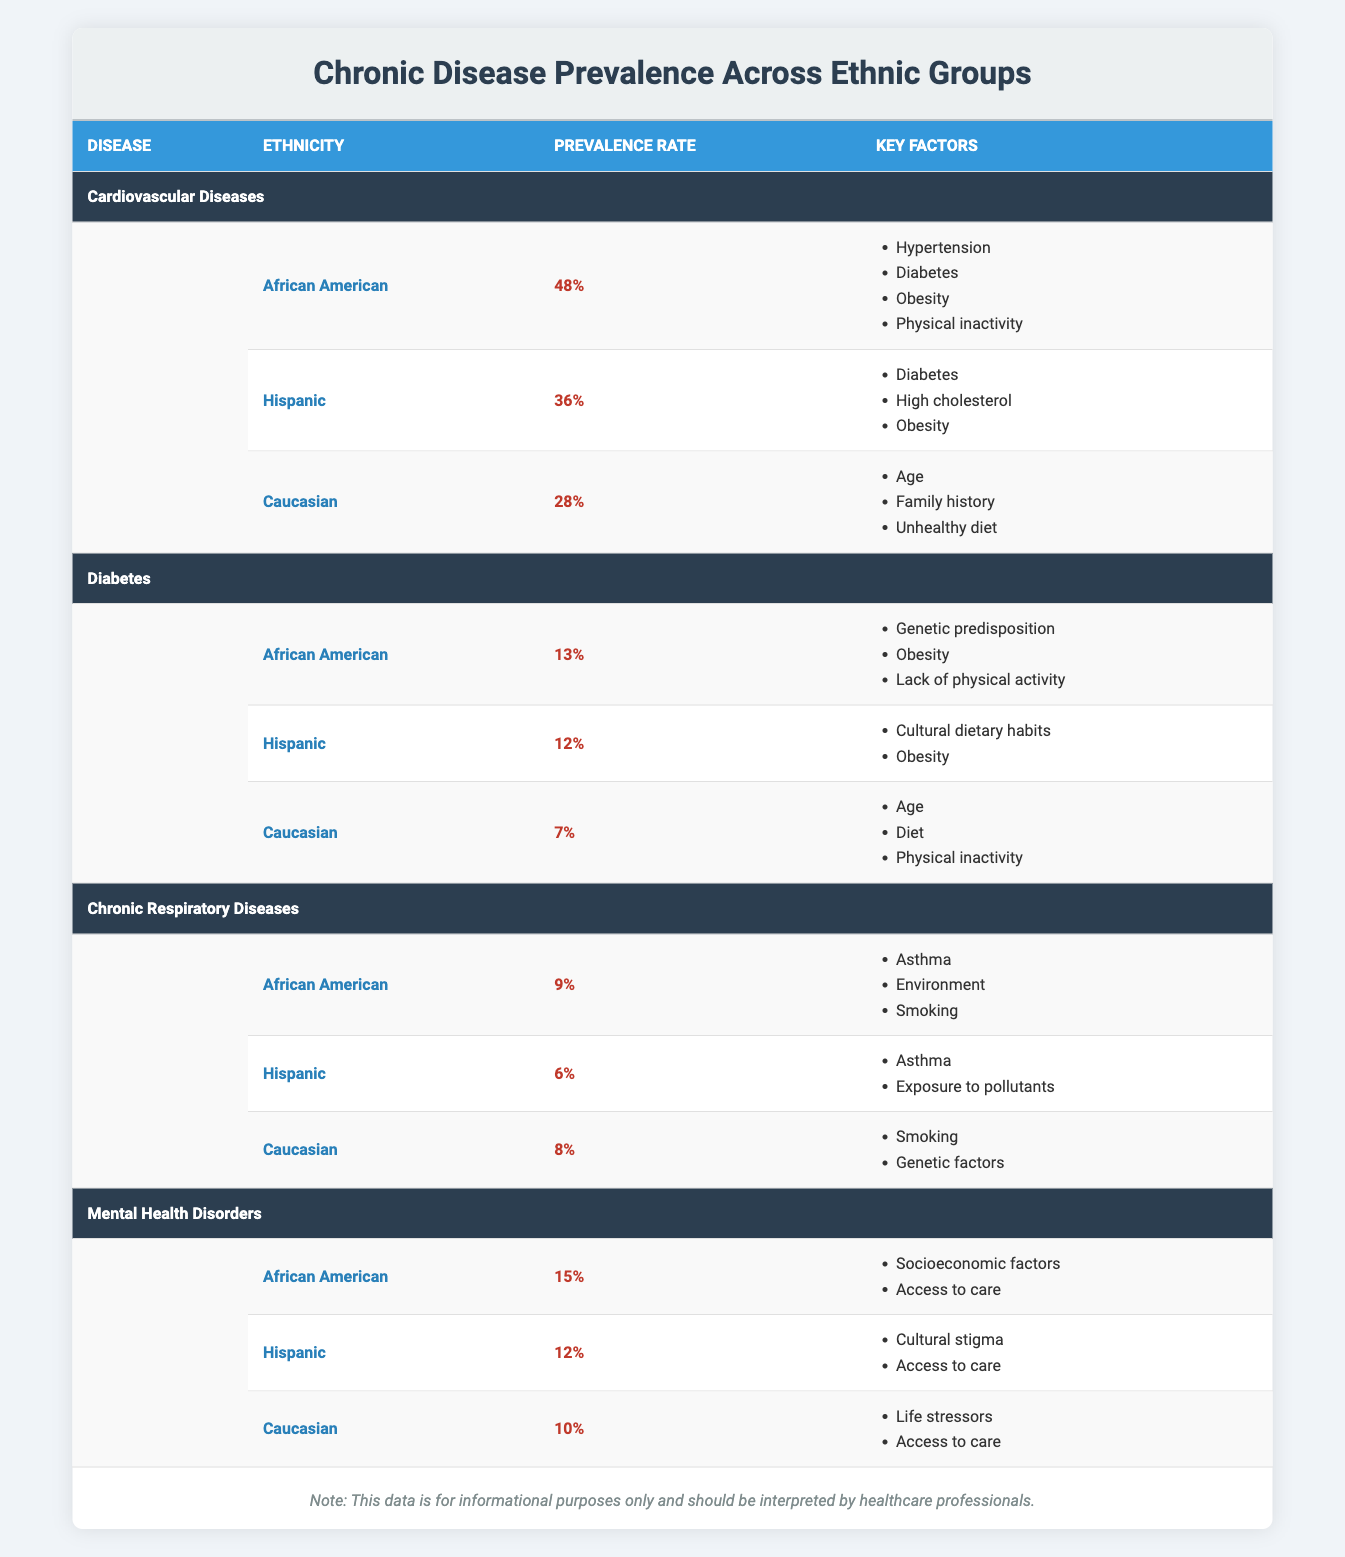What is the prevalence rate of Cardiovascular Diseases among Caucasians? The table indicates that the prevalence rate for Caucasians is listed under the Cardiovascular Diseases category. It's found in the fourth row of that section, where "Caucasian" is mentioned alongside its corresponding prevalence rate of 28%.
Answer: 28% Which ethnic group has the highest prevalence of Diabetes? In the Diabetes section of the table, the prevalence rates are compared for African American (13%), Hispanic (12%), and Caucasian (7%). The African American group has the highest percentage, making it easy to determine that their rate is greater than both Hispanic and Caucasian.
Answer: African American Are chronic respiratory diseases more prevalent in Hispanic or Caucasian populations? The table provides a prevalence rate of 6% for Hispanics and 8% for Caucasians under the Chronic Respiratory Diseases section. By comparing these values, it is clear that the prevalence is higher in Caucasians.
Answer: Yes What is the average prevalence rate of Mental Health Disorders across all ethnic groups? To find the average, we take the prevalence rates from the Mental Health Disorders section: African American (15%), Hispanic (12%), and Caucasian (10%). The sum of these values is 15 + 12 + 10 = 37, and dividing by the number of groups (3) gives an average rate of 37/3.
Answer: 12.33% Is there a higher prevalence of Chronic Respiratory Diseases in African Americans compared to Hispanics? According to the table, African Americans have a prevalence rate of 9% while Hispanics have 6%. The comparison shows that African Americans have a higher prevalence rate than Hispanics for Chronic Respiratory Diseases.
Answer: Yes What are the key factors contributing to Cardiovascular Diseases for the Hispanic group? The table details the key factors associated with the Hispanic group under the Cardiovascular Diseases category, which include Diabetes, High cholesterol, and Obesity. These factors can be found by locating the Hispanic ethnicity within the Cardiovascular Diseases section and reading the listed key factors.
Answer: Diabetes, High cholesterol, Obesity How much more prevalent are Cardiovascular Diseases in African Americans compared to Caucasians? The prevalence rates for African Americans is 48% and for Caucasians is 28%. To determine the difference, we subtract Caucasian's rate from African American's rate: 48% - 28% = 20%. Therefore, there is a 20% higher prevalence in African Americans compared to Caucasians.
Answer: 20% Which ethnic group has the lowest prevalence of all diseases listed in the table? By examining the prevalence rates across all chronic diseases, we see that Caucasians have the lowest rate for Diabetes at 7%, while other diseases show higher rates for at least one ethnic group. This confirms that Caucasians show the overall lowest rate for Diabetes specifically.
Answer: Caucasian for Diabetes 